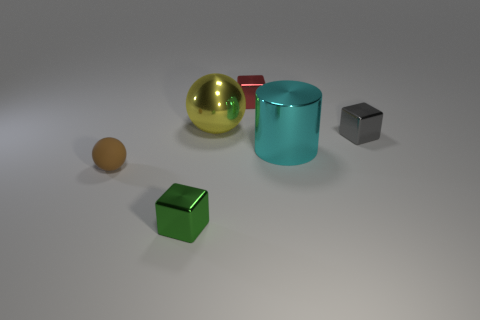Is the shape of the yellow object the same as the gray metal object?
Your answer should be very brief. No. Is there anything else that is made of the same material as the tiny brown thing?
Offer a terse response. No. Does the metallic cube behind the large yellow metal thing have the same size as the ball that is on the right side of the tiny green cube?
Your answer should be compact. No. There is a tiny thing that is behind the green metallic object and in front of the gray metal block; what is it made of?
Your response must be concise. Rubber. Are there any other things of the same color as the cylinder?
Keep it short and to the point. No. Is the number of red things that are to the left of the yellow shiny object less than the number of cyan objects?
Ensure brevity in your answer.  Yes. Are there more big shiny cylinders than large red metallic spheres?
Your answer should be compact. Yes. Are there any small gray metallic blocks in front of the large thing on the right side of the large metallic thing that is behind the tiny gray object?
Your answer should be compact. No. What number of other things are there of the same size as the brown ball?
Offer a very short reply. 3. Are there any tiny brown objects on the right side of the small gray thing?
Make the answer very short. No. 